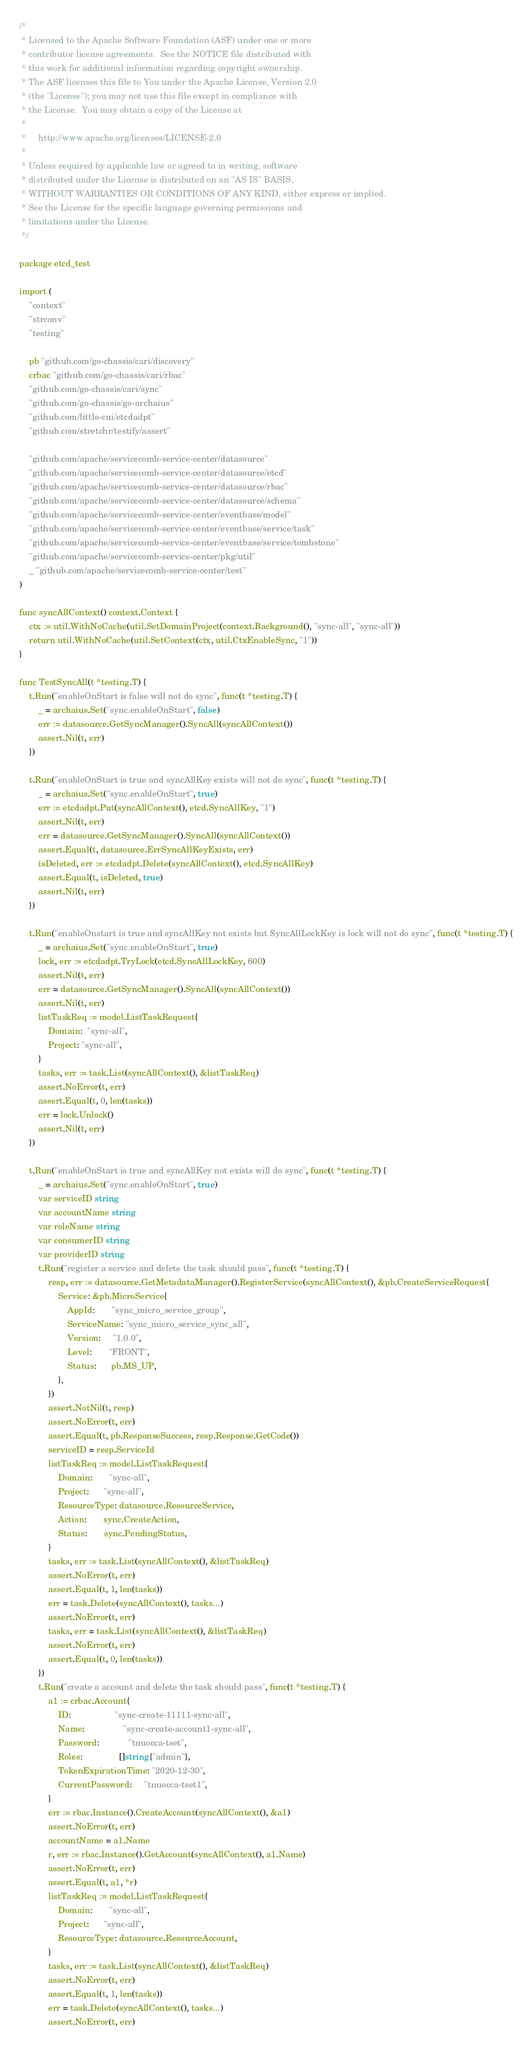Convert code to text. <code><loc_0><loc_0><loc_500><loc_500><_Go_>/*
 * Licensed to the Apache Software Foundation (ASF) under one or more
 * contributor license agreements.  See the NOTICE file distributed with
 * this work for additional information regarding copyright ownership.
 * The ASF licenses this file to You under the Apache License, Version 2.0
 * (the "License"); you may not use this file except in compliance with
 * the License.  You may obtain a copy of the License at
 *
 *     http://www.apache.org/licenses/LICENSE-2.0
 *
 * Unless required by applicable law or agreed to in writing, software
 * distributed under the License is distributed on an "AS IS" BASIS,
 * WITHOUT WARRANTIES OR CONDITIONS OF ANY KIND, either express or implied.
 * See the License for the specific language governing permissions and
 * limitations under the License.
 */

package etcd_test

import (
	"context"
	"strconv"
	"testing"

	pb "github.com/go-chassis/cari/discovery"
	crbac "github.com/go-chassis/cari/rbac"
	"github.com/go-chassis/cari/sync"
	"github.com/go-chassis/go-archaius"
	"github.com/little-cui/etcdadpt"
	"github.com/stretchr/testify/assert"

	"github.com/apache/servicecomb-service-center/datasource"
	"github.com/apache/servicecomb-service-center/datasource/etcd"
	"github.com/apache/servicecomb-service-center/datasource/rbac"
	"github.com/apache/servicecomb-service-center/datasource/schema"
	"github.com/apache/servicecomb-service-center/eventbase/model"
	"github.com/apache/servicecomb-service-center/eventbase/service/task"
	"github.com/apache/servicecomb-service-center/eventbase/service/tombstone"
	"github.com/apache/servicecomb-service-center/pkg/util"
	_ "github.com/apache/servicecomb-service-center/test"
)

func syncAllContext() context.Context {
	ctx := util.WithNoCache(util.SetDomainProject(context.Background(), "sync-all", "sync-all"))
	return util.WithNoCache(util.SetContext(ctx, util.CtxEnableSync, "1"))
}

func TestSyncAll(t *testing.T) {
	t.Run("enableOnStart is false will not do sync", func(t *testing.T) {
		_ = archaius.Set("sync.enableOnStart", false)
		err := datasource.GetSyncManager().SyncAll(syncAllContext())
		assert.Nil(t, err)
	})

	t.Run("enableOnStart is true and syncAllKey exists will not do sync", func(t *testing.T) {
		_ = archaius.Set("sync.enableOnStart", true)
		err := etcdadpt.Put(syncAllContext(), etcd.SyncAllKey, "1")
		assert.Nil(t, err)
		err = datasource.GetSyncManager().SyncAll(syncAllContext())
		assert.Equal(t, datasource.ErrSyncAllKeyExists, err)
		isDeleted, err := etcdadpt.Delete(syncAllContext(), etcd.SyncAllKey)
		assert.Equal(t, isDeleted, true)
		assert.Nil(t, err)
	})

	t.Run("enableOnstart is true and syncAllKey not exists but SyncAllLockKey is lock will not do sync", func(t *testing.T) {
		_ = archaius.Set("sync.enableOnStart", true)
		lock, err := etcdadpt.TryLock(etcd.SyncAllLockKey, 600)
		assert.Nil(t, err)
		err = datasource.GetSyncManager().SyncAll(syncAllContext())
		assert.Nil(t, err)
		listTaskReq := model.ListTaskRequest{
			Domain:  "sync-all",
			Project: "sync-all",
		}
		tasks, err := task.List(syncAllContext(), &listTaskReq)
		assert.NoError(t, err)
		assert.Equal(t, 0, len(tasks))
		err = lock.Unlock()
		assert.Nil(t, err)
	})

	t.Run("enableOnStart is true and syncAllKey not exists will do sync", func(t *testing.T) {
		_ = archaius.Set("sync.enableOnStart", true)
		var serviceID string
		var accountName string
		var roleName string
		var consumerID string
		var providerID string
		t.Run("register a service and delete the task should pass", func(t *testing.T) {
			resp, err := datasource.GetMetadataManager().RegisterService(syncAllContext(), &pb.CreateServiceRequest{
				Service: &pb.MicroService{
					AppId:       "sync_micro_service_group",
					ServiceName: "sync_micro_service_sync_all",
					Version:     "1.0.0",
					Level:       "FRONT",
					Status:      pb.MS_UP,
				},
			})
			assert.NotNil(t, resp)
			assert.NoError(t, err)
			assert.Equal(t, pb.ResponseSuccess, resp.Response.GetCode())
			serviceID = resp.ServiceId
			listTaskReq := model.ListTaskRequest{
				Domain:       "sync-all",
				Project:      "sync-all",
				ResourceType: datasource.ResourceService,
				Action:       sync.CreateAction,
				Status:       sync.PendingStatus,
			}
			tasks, err := task.List(syncAllContext(), &listTaskReq)
			assert.NoError(t, err)
			assert.Equal(t, 1, len(tasks))
			err = task.Delete(syncAllContext(), tasks...)
			assert.NoError(t, err)
			tasks, err = task.List(syncAllContext(), &listTaskReq)
			assert.NoError(t, err)
			assert.Equal(t, 0, len(tasks))
		})
		t.Run("create a account and delete the task should pass", func(t *testing.T) {
			a1 := crbac.Account{
				ID:                  "sync-create-11111-sync-all",
				Name:                "sync-create-account1-sync-all",
				Password:            "tnuocca-tset",
				Roles:               []string{"admin"},
				TokenExpirationTime: "2020-12-30",
				CurrentPassword:     "tnuocca-tset1",
			}
			err := rbac.Instance().CreateAccount(syncAllContext(), &a1)
			assert.NoError(t, err)
			accountName = a1.Name
			r, err := rbac.Instance().GetAccount(syncAllContext(), a1.Name)
			assert.NoError(t, err)
			assert.Equal(t, a1, *r)
			listTaskReq := model.ListTaskRequest{
				Domain:       "sync-all",
				Project:      "sync-all",
				ResourceType: datasource.ResourceAccount,
			}
			tasks, err := task.List(syncAllContext(), &listTaskReq)
			assert.NoError(t, err)
			assert.Equal(t, 1, len(tasks))
			err = task.Delete(syncAllContext(), tasks...)
			assert.NoError(t, err)</code> 